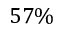<formula> <loc_0><loc_0><loc_500><loc_500>5 7 \%</formula> 